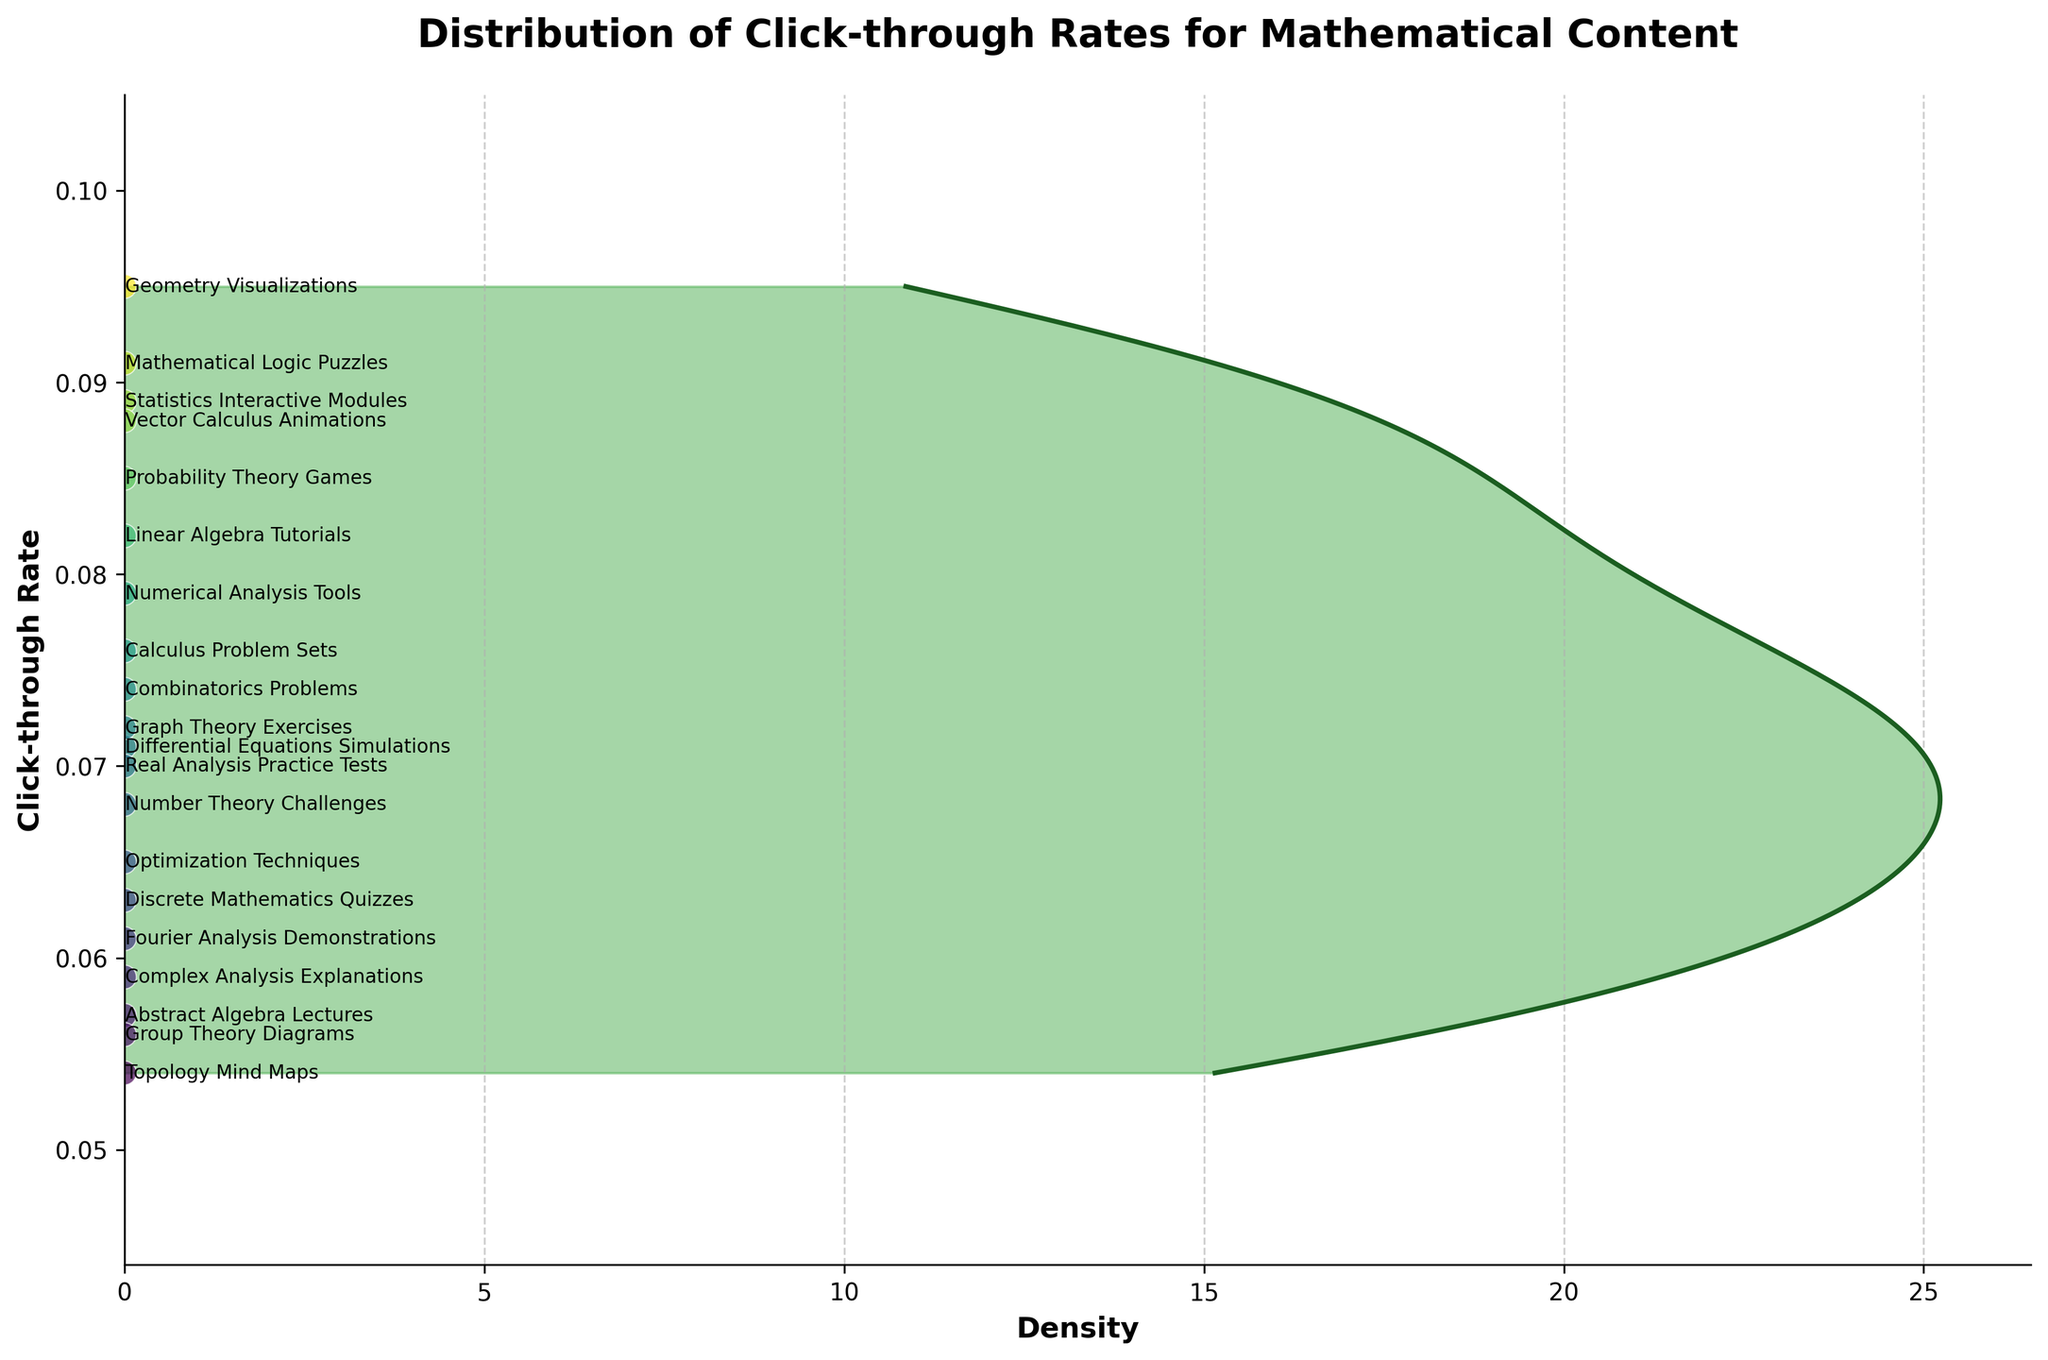What is the title of the plot? The title can be found at the top of the plot and it provides a quick summary of what the plot represents. In this case, the title is clearly mentioned at the top of the plot.
Answer: "Distribution of Click-through Rates for Mathematical Content" What are the labels of the axes? The axes labels provide context for what is being measured on each axis. In this plot, the x-axis label "Density" represents the density of click-through rates, and the y-axis label "Click-through Rate" represents the rates themselves.
Answer: "Density" and "Click-through Rate" How many different content types are included in the plot? By looking at the number of scatter points on the density plot and identifying the unique labels associated with each point, we can determine the number of distinct content types. There are scatter points along the density curve, each representing a different content type.
Answer: 19 What is the highest click-through rate observed, and which content type does it correspond to? To answer this, locate the scatter point with the highest position on the y-axis and identify the label next to it. The highest point corresponds to "Geometry Visualizations" with a click-through rate of 0.095.
Answer: 0.095, "Geometry Visualizations" Which content type has the lowest click-through rate? Identify the scatter point at the lowest position on the y-axis. The label next to this point indicates the content type with the lowest click-through rate. The content type at the lowest position is "Topology Mind Maps" with a rate of 0.054.
Answer: "Topology Mind Maps" What is the general trend observed in the density plot for click-through rates? By observing the density curve, you can generally tell where the highest concentration of click-through rates lies. The density curve shows a peak between 0.06 and 0.09, indicating that most click-through rates fall within this range.
Answer: Most values lie between 0.06 and 0.09 How does the click-through rate for "Probability Theory Games" compare to "Mathematical Logic Puzzles"? Locate the scatter points for both content types and compare their positions on the y-axis. "Probability Theory Games" has a rate of 0.085, and "Mathematical Logic Puzzles" has a rate of 0.091. So, "Mathematical Logic Puzzles" has a slightly higher click-through rate.
Answer: "Mathematical Logic Puzzles" is higher What is the median click-through rate? To find the median click-through rate, you would arrange all click-through rates in ascending order and find the middle value. Here, sorting the 19 click-through rates and finding the 10th value (since 19 is odd) gives us the median.
Answer: 0.076 How are the click-through rates distributed across the content types? By examining the shape of the density curve, you can describe the distribution. The curve has a peak, indicating a higher density of rates around 0.07 to 0.09, with gradual tails indicating fewer content types with very low or very high click-through rates.
Answer: Peaks around 0.07 to 0.09, few extremes What does the scatter plot of points in the density curve represent? The scatter plot points align with the density curve and each point is labeled with a content type, showing the actual click-through rates for the various content types. This helps in identifying individual data points within the overall distribution.
Answer: Individual content types and their rates 